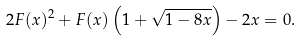Convert formula to latex. <formula><loc_0><loc_0><loc_500><loc_500>2 F ( x ) ^ { 2 } + F ( x ) \left ( 1 + \sqrt { 1 - 8 x } \right ) - 2 x = 0 .</formula> 